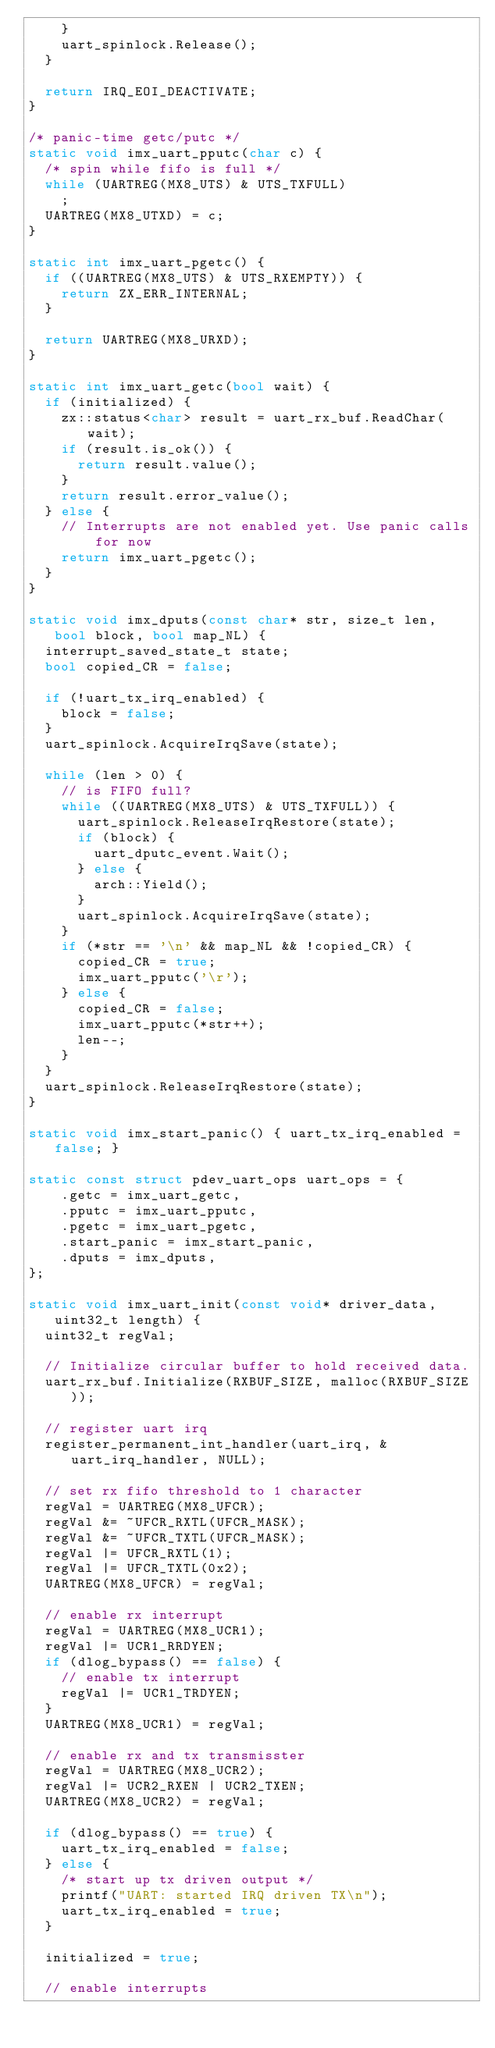<code> <loc_0><loc_0><loc_500><loc_500><_C++_>    }
    uart_spinlock.Release();
  }

  return IRQ_EOI_DEACTIVATE;
}

/* panic-time getc/putc */
static void imx_uart_pputc(char c) {
  /* spin while fifo is full */
  while (UARTREG(MX8_UTS) & UTS_TXFULL)
    ;
  UARTREG(MX8_UTXD) = c;
}

static int imx_uart_pgetc() {
  if ((UARTREG(MX8_UTS) & UTS_RXEMPTY)) {
    return ZX_ERR_INTERNAL;
  }

  return UARTREG(MX8_URXD);
}

static int imx_uart_getc(bool wait) {
  if (initialized) {
    zx::status<char> result = uart_rx_buf.ReadChar(wait);
    if (result.is_ok()) {
      return result.value();
    }
    return result.error_value();
  } else {
    // Interrupts are not enabled yet. Use panic calls for now
    return imx_uart_pgetc();
  }
}

static void imx_dputs(const char* str, size_t len, bool block, bool map_NL) {
  interrupt_saved_state_t state;
  bool copied_CR = false;

  if (!uart_tx_irq_enabled) {
    block = false;
  }
  uart_spinlock.AcquireIrqSave(state);

  while (len > 0) {
    // is FIFO full?
    while ((UARTREG(MX8_UTS) & UTS_TXFULL)) {
      uart_spinlock.ReleaseIrqRestore(state);
      if (block) {
        uart_dputc_event.Wait();
      } else {
        arch::Yield();
      }
      uart_spinlock.AcquireIrqSave(state);
    }
    if (*str == '\n' && map_NL && !copied_CR) {
      copied_CR = true;
      imx_uart_pputc('\r');
    } else {
      copied_CR = false;
      imx_uart_pputc(*str++);
      len--;
    }
  }
  uart_spinlock.ReleaseIrqRestore(state);
}

static void imx_start_panic() { uart_tx_irq_enabled = false; }

static const struct pdev_uart_ops uart_ops = {
    .getc = imx_uart_getc,
    .pputc = imx_uart_pputc,
    .pgetc = imx_uart_pgetc,
    .start_panic = imx_start_panic,
    .dputs = imx_dputs,
};

static void imx_uart_init(const void* driver_data, uint32_t length) {
  uint32_t regVal;

  // Initialize circular buffer to hold received data.
  uart_rx_buf.Initialize(RXBUF_SIZE, malloc(RXBUF_SIZE));

  // register uart irq
  register_permanent_int_handler(uart_irq, &uart_irq_handler, NULL);

  // set rx fifo threshold to 1 character
  regVal = UARTREG(MX8_UFCR);
  regVal &= ~UFCR_RXTL(UFCR_MASK);
  regVal &= ~UFCR_TXTL(UFCR_MASK);
  regVal |= UFCR_RXTL(1);
  regVal |= UFCR_TXTL(0x2);
  UARTREG(MX8_UFCR) = regVal;

  // enable rx interrupt
  regVal = UARTREG(MX8_UCR1);
  regVal |= UCR1_RRDYEN;
  if (dlog_bypass() == false) {
    // enable tx interrupt
    regVal |= UCR1_TRDYEN;
  }
  UARTREG(MX8_UCR1) = regVal;

  // enable rx and tx transmisster
  regVal = UARTREG(MX8_UCR2);
  regVal |= UCR2_RXEN | UCR2_TXEN;
  UARTREG(MX8_UCR2) = regVal;

  if (dlog_bypass() == true) {
    uart_tx_irq_enabled = false;
  } else {
    /* start up tx driven output */
    printf("UART: started IRQ driven TX\n");
    uart_tx_irq_enabled = true;
  }

  initialized = true;

  // enable interrupts</code> 